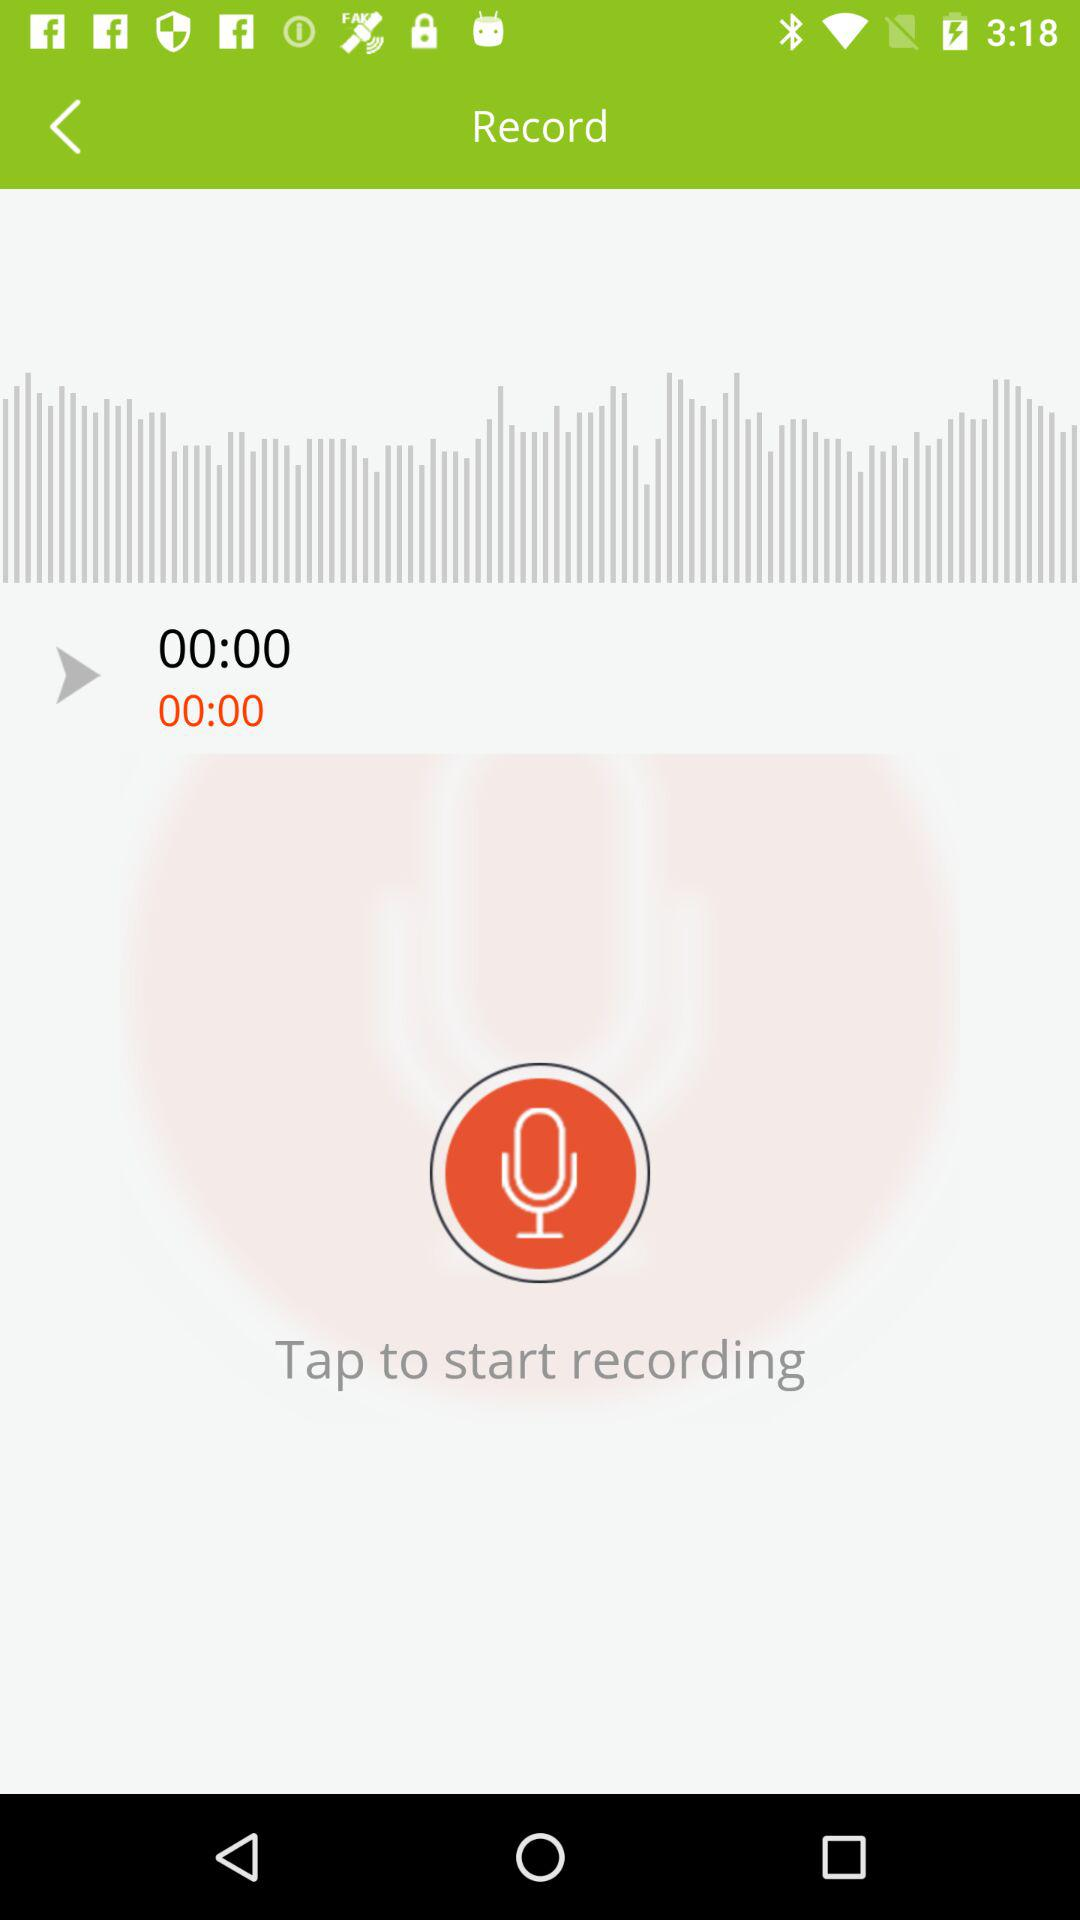How many seconds has the recording been going on for?
Answer the question using a single word or phrase. 0 